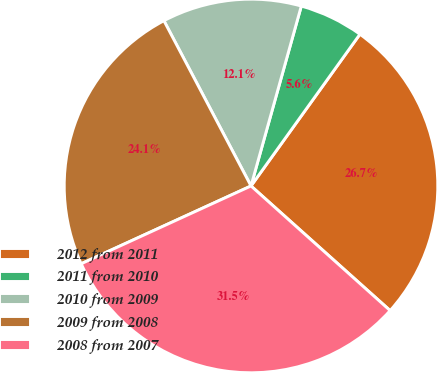Convert chart to OTSL. <chart><loc_0><loc_0><loc_500><loc_500><pie_chart><fcel>2012 from 2011<fcel>2011 from 2010<fcel>2010 from 2009<fcel>2009 from 2008<fcel>2008 from 2007<nl><fcel>26.72%<fcel>5.57%<fcel>12.06%<fcel>24.12%<fcel>31.54%<nl></chart> 